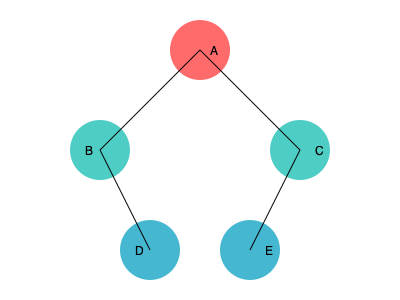In the given social network graph, which node has the highest betweenness centrality, and how does this reflect the power dynamics within the network? Explain the implications for information flow and potential for subversion within this hierarchical structure. To analyze the power dynamics in this social network graph, we need to understand betweenness centrality and its implications:

1. Betweenness Centrality: This measure quantifies the number of times a node acts as a bridge along the shortest path between two other nodes. It's calculated as:

   $$BC(v) = \sum_{s \neq v \neq t} \frac{\sigma_{st}(v)}{\sigma_{st}}$$

   where $\sigma_{st}$ is the total number of shortest paths from node s to node t, and $\sigma_{st}(v)$ is the number of those paths that pass through v.

2. Analyzing the graph:
   - Node A is connected to B and C
   - B is connected to A and D
   - C is connected to A and E
   - D and E are only connected to B and C respectively

3. Calculating betweenness centrality:
   - Node A lies on 4 shortest paths: B-C, B-E, C-D, D-E
   - Nodes B and C each lie on 1 shortest path: D-A and E-A respectively
   - Nodes D and E don't lie on any shortest paths between other nodes

4. Power dynamics:
   - Node A has the highest betweenness centrality, indicating it has the most control over information flow in the network
   - This reflects a hierarchical structure with A at the top, B and C as middle management, and D and E as lower-level nodes

5. Implications for information flow:
   - A acts as a gatekeeper, potentially filtering or manipulating information between upper and lower levels
   - This centralization creates a single point of failure or control

6. Potential for subversion:
   - Targeting node A could significantly disrupt the entire network
   - Alternatively, creating direct connections between B-C or D-E could decentralize power and reduce A's influence

This analysis reveals how centralized power structures in networks can be identified and potentially challenged, aligning with anarchist critiques of hierarchical systems.
Answer: Node A; highest control over information flow, reflecting hierarchical power structure vulnerable to disruption or decentralization. 